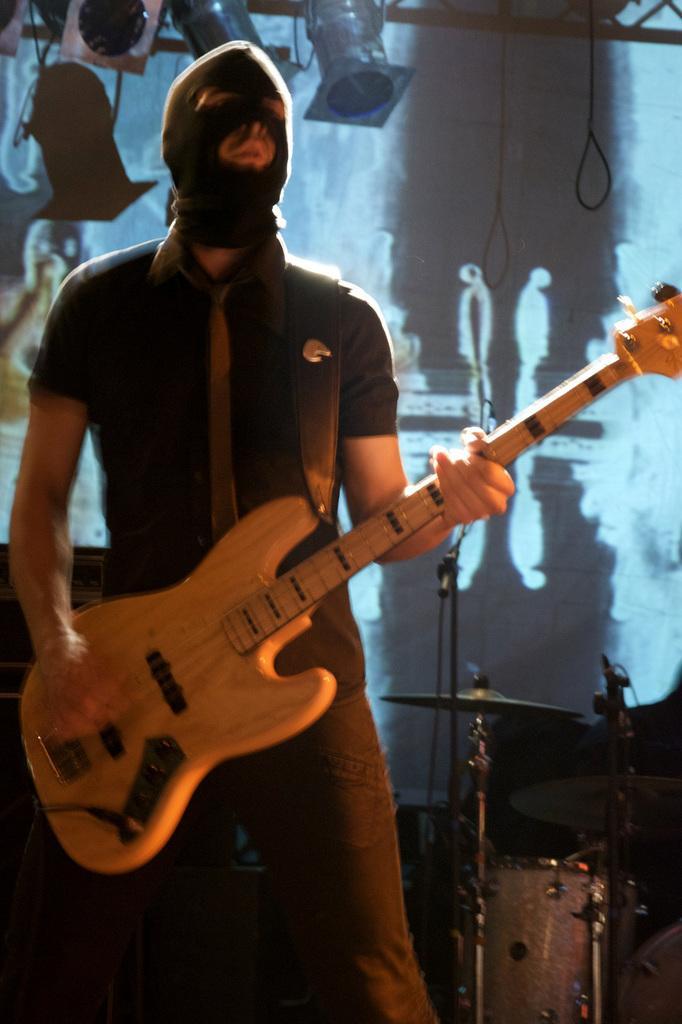Could you give a brief overview of what you see in this image? In this picture there is a man who is standing at the left side of the image, by holding the guitar in his hands and wearing a face mask over his face and there are some spotlights behind the man at the left side of the image, there is a drum set at the right side of the image. 